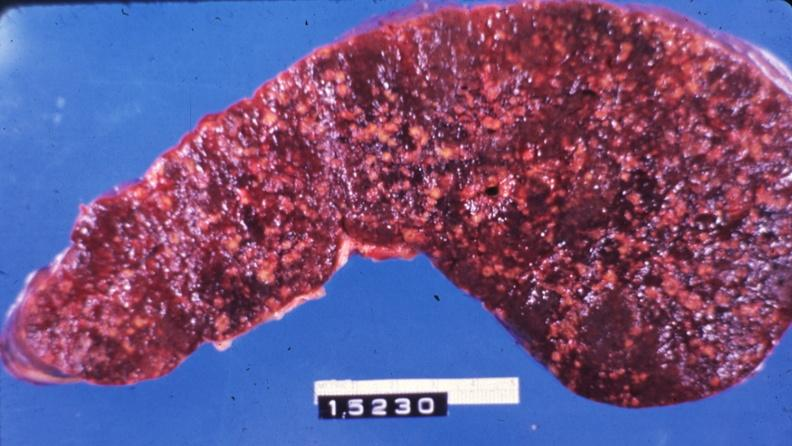s malignant histiocytosis present?
Answer the question using a single word or phrase. Yes 